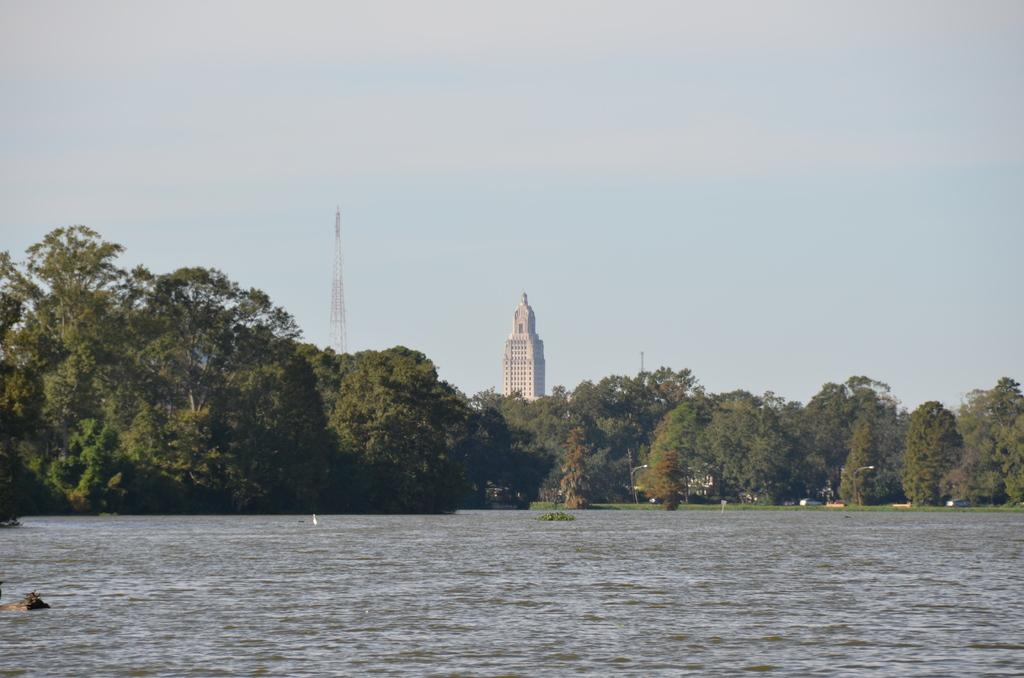What type of natural feature is present in the image? There is a lake in the image. What type of vegetation can be seen in the image? There are trees in the image. What structures are visible in the background of the image? There is a building and a tower in the background of the image. What is visible at the top of the image? The sky is visible at the top of the image. What type of health advice can be seen written on the trees in the image? There is no health advice written on the trees in the image; it features a lake, trees, a building, a tower, and the sky. 